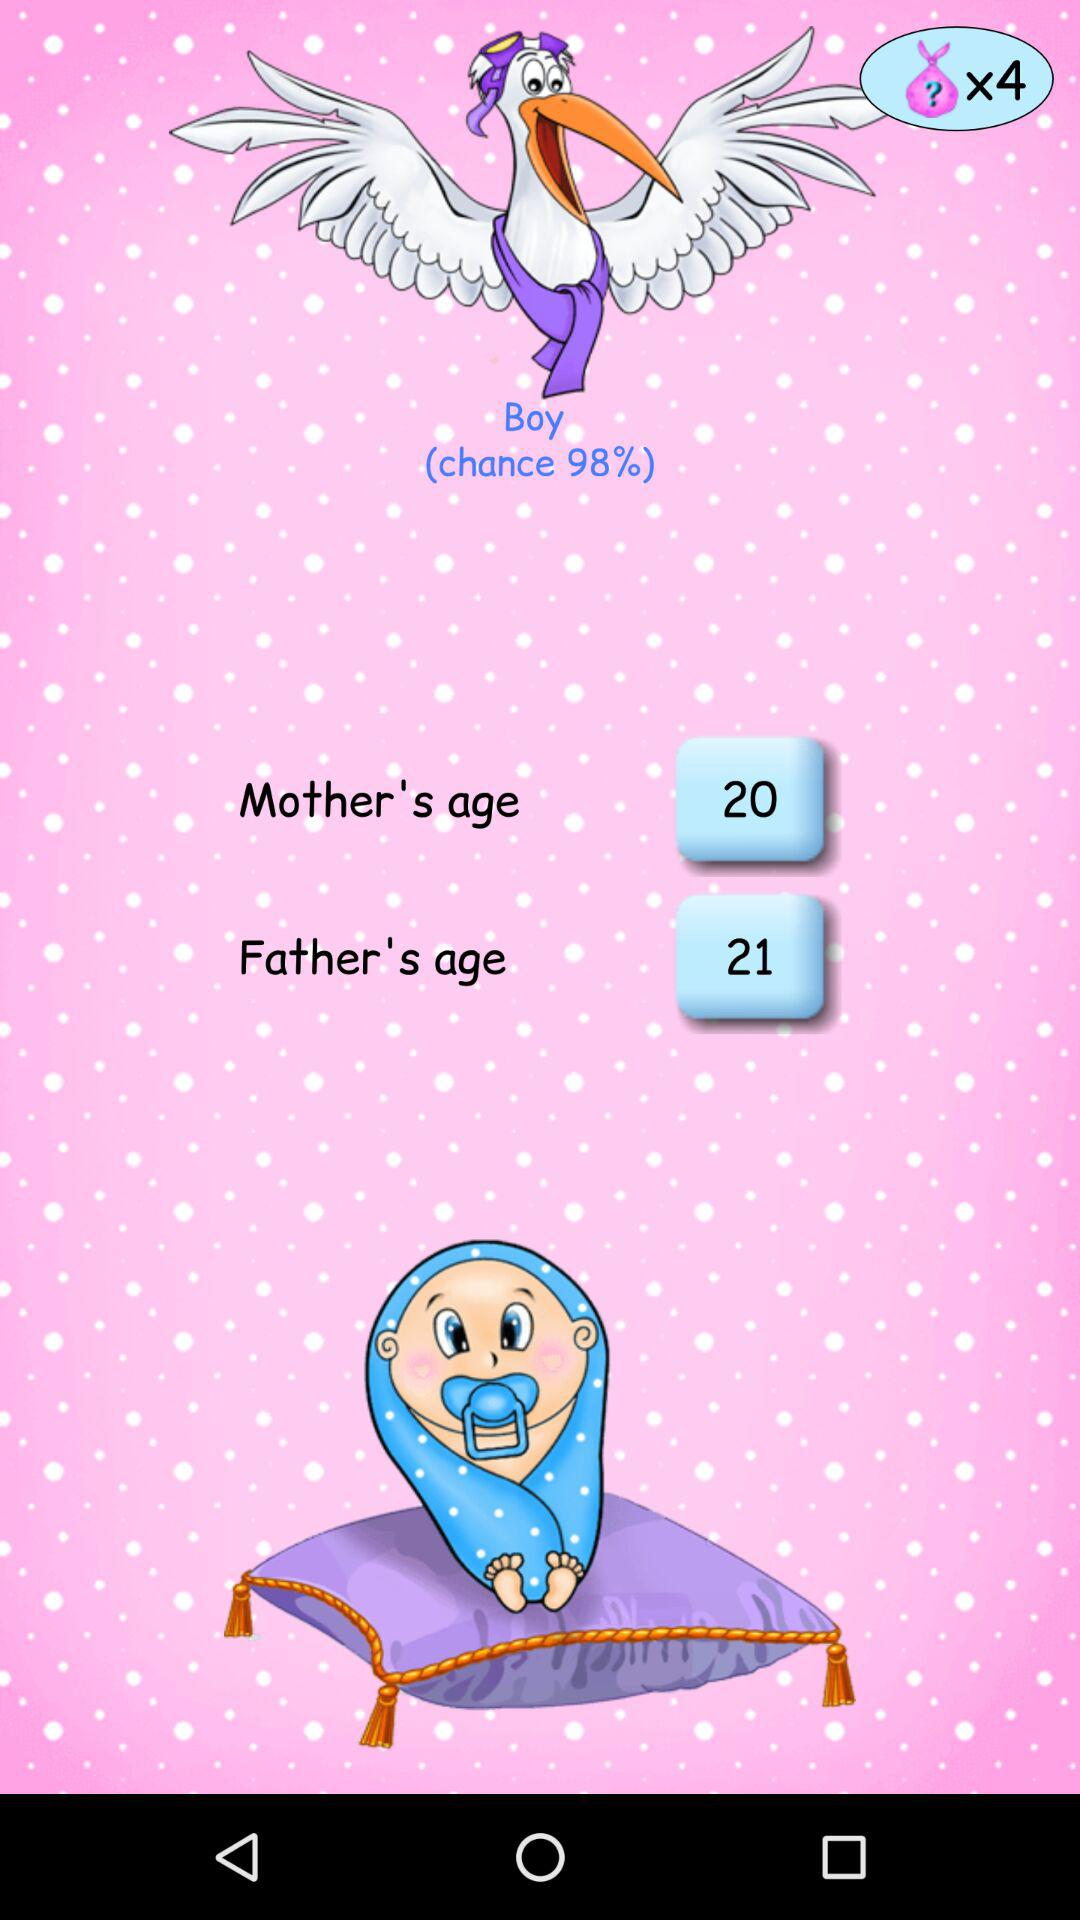What is the age of the father? The age of the father is 21. 